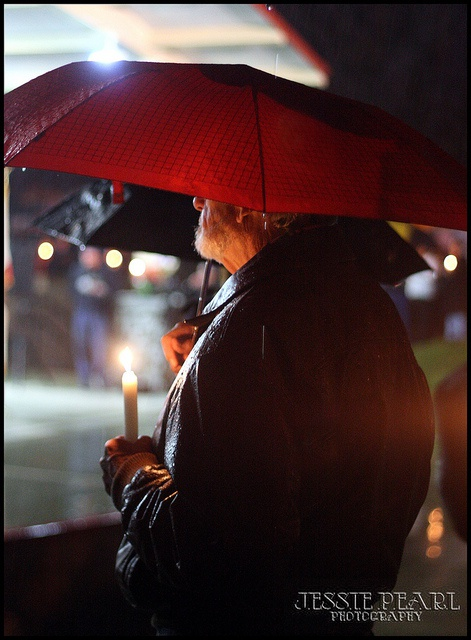Describe the objects in this image and their specific colors. I can see people in black, maroon, and gray tones, umbrella in black, maroon, and purple tones, and umbrella in black, gray, and maroon tones in this image. 